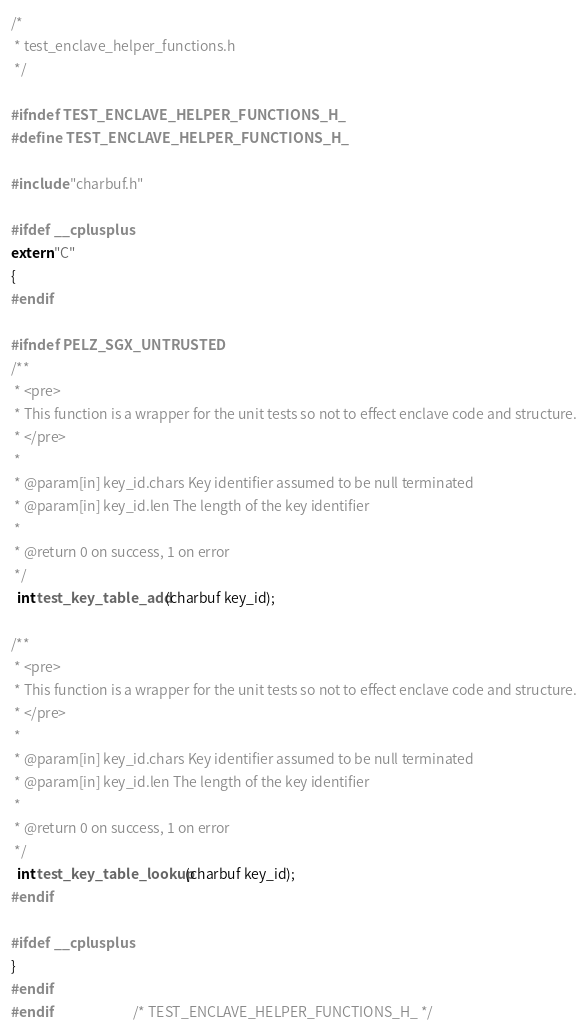<code> <loc_0><loc_0><loc_500><loc_500><_C_>/*
 * test_enclave_helper_functions.h
 */

#ifndef TEST_ENCLAVE_HELPER_FUNCTIONS_H_
#define TEST_ENCLAVE_HELPER_FUNCTIONS_H_

#include "charbuf.h"

#ifdef __cplusplus
extern "C"
{
#endif

#ifndef PELZ_SGX_UNTRUSTED
/**
 * <pre>
 * This function is a wrapper for the unit tests so not to effect enclave code and structure.
 * </pre>
 *
 * @param[in] key_id.chars Key identifier assumed to be null terminated
 * @param[in] key_id.len The length of the key identifier
 *
 * @return 0 on success, 1 on error
 */
  int test_key_table_add(charbuf key_id);

/**
 * <pre>
 * This function is a wrapper for the unit tests so not to effect enclave code and structure.
 * </pre>
 *
 * @param[in] key_id.chars Key identifier assumed to be null terminated
 * @param[in] key_id.len The length of the key identifier
 *
 * @return 0 on success, 1 on error
 */
  int test_key_table_lookup(charbuf key_id);
#endif

#ifdef __cplusplus
}
#endif
#endif                          /* TEST_ENCLAVE_HELPER_FUNCTIONS_H_ */
</code> 